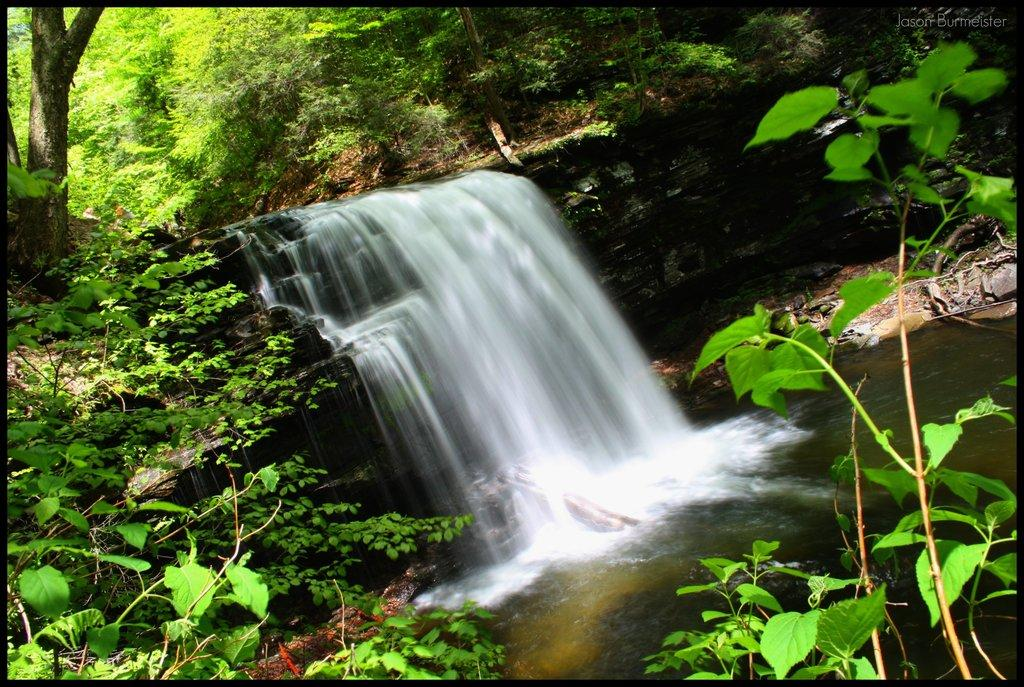What is the main subject of the image? The main subject of the image is a waterfall. Where is the waterfall located in the image? The waterfall is in the middle of the image. What can be seen on either side of the waterfall? There are plants and trees on either side of the waterfall. Can you tell me how many bananas are hanging from the trees in the image? There are no bananas visible in the image; only plants and trees are present. What type of room is shown in the image? The image does not depict a room; it features a waterfall and its surroundings. 